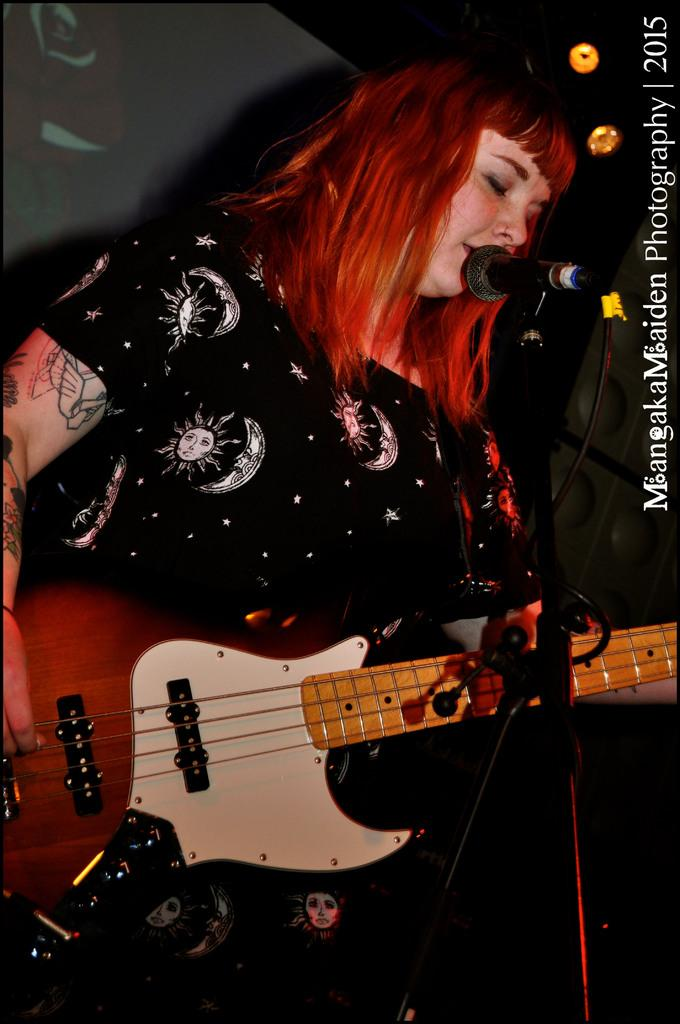Who is the main subject in the image? There is a woman in the image. What is the woman wearing? The woman is wearing a black dress. What is the woman doing in the image? The woman is singing a song and playing a guitar. What is the woman using to amplify her voice? There is a microphone in the image, which is attached to a microphone stand. Can you see the woman's badge in the image? There is no badge visible in the image. What scene is the woman performing in the image? The image does not depict a specific scene; it simply shows the woman singing and playing the guitar. 